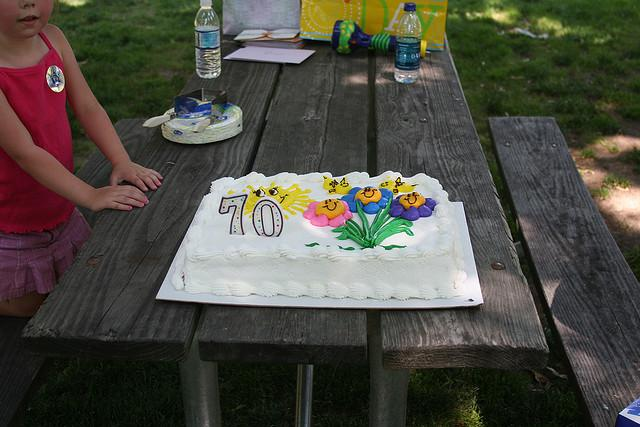What item is drawn on the cake? flowers 